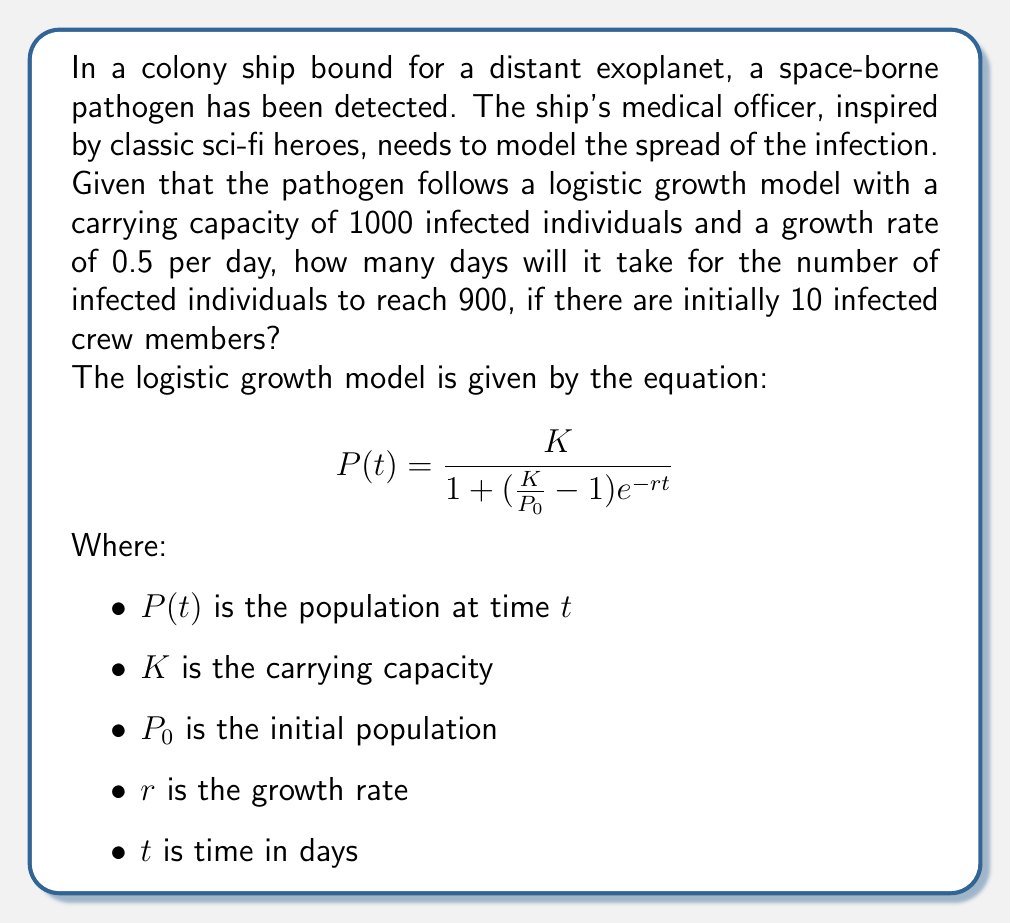Can you answer this question? To solve this problem, we need to use the logistic growth equation and solve for $t$ when $P(t) = 900$. Let's break it down step by step:

1) We're given:
   $K = 1000$ (carrying capacity)
   $P_0 = 10$ (initial infected population)
   $r = 0.5$ (growth rate per day)
   $P(t) = 900$ (target infected population)

2) Let's substitute these values into the logistic growth equation:

   $$900 = \frac{1000}{1 + (\frac{1000}{10} - 1)e^{-0.5t}}$$

3) Simplify the fraction inside the parentheses:

   $$900 = \frac{1000}{1 + 99e^{-0.5t}}$$

4) Multiply both sides by the denominator:

   $$900(1 + 99e^{-0.5t}) = 1000$$

5) Distribute on the left side:

   $$900 + 89100e^{-0.5t} = 1000$$

6) Subtract 900 from both sides:

   $$89100e^{-0.5t} = 100$$

7) Divide both sides by 89100:

   $$e^{-0.5t} = \frac{1}{891}$$

8) Take the natural log of both sides:

   $$-0.5t = \ln(\frac{1}{891})$$

9) Divide both sides by -0.5:

   $$t = -\frac{2\ln(\frac{1}{891})}{1} = 2\ln(891)$$

10) Calculate the final value:

    $$t \approx 13.57$$

Therefore, it will take approximately 13.57 days for the number of infected individuals to reach 900.
Answer: 13.57 days 